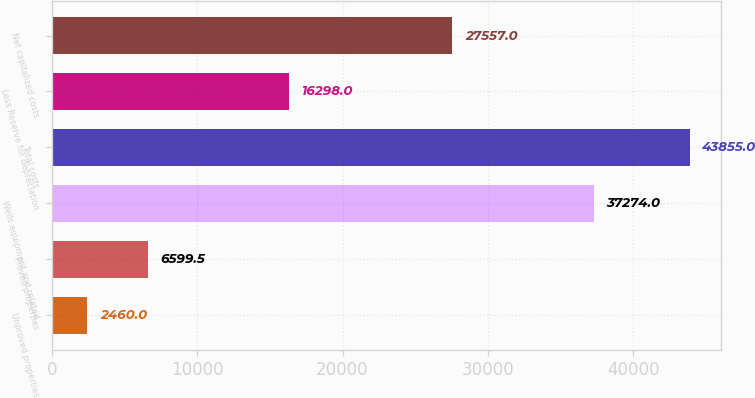Convert chart. <chart><loc_0><loc_0><loc_500><loc_500><bar_chart><fcel>Unproved properties<fcel>Proved properties<fcel>Wells equipment and related<fcel>Total costs<fcel>Less Reserve for depreciation<fcel>Net capitalized costs<nl><fcel>2460<fcel>6599.5<fcel>37274<fcel>43855<fcel>16298<fcel>27557<nl></chart> 